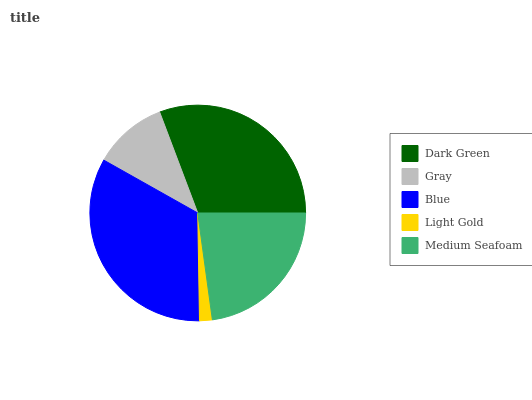Is Light Gold the minimum?
Answer yes or no. Yes. Is Blue the maximum?
Answer yes or no. Yes. Is Gray the minimum?
Answer yes or no. No. Is Gray the maximum?
Answer yes or no. No. Is Dark Green greater than Gray?
Answer yes or no. Yes. Is Gray less than Dark Green?
Answer yes or no. Yes. Is Gray greater than Dark Green?
Answer yes or no. No. Is Dark Green less than Gray?
Answer yes or no. No. Is Medium Seafoam the high median?
Answer yes or no. Yes. Is Medium Seafoam the low median?
Answer yes or no. Yes. Is Gray the high median?
Answer yes or no. No. Is Light Gold the low median?
Answer yes or no. No. 